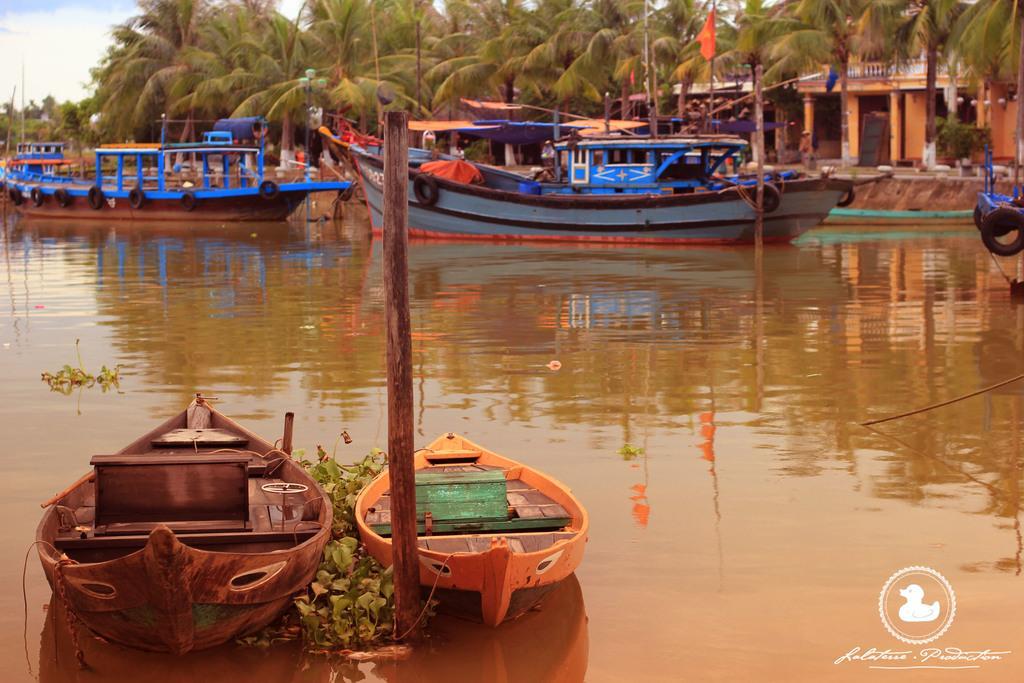Describe this image in one or two sentences. In this image, on the left side, we can see two ships which are drowning in the water, we can also see a wooden pole and some plants in the water. On the right side, we can see a ship, building, trees. In the background, we can also see some ships which are drowning on the water, building, trees. At the top, we can see a sky, at the bottom, we can see water in a lake and some plants. 